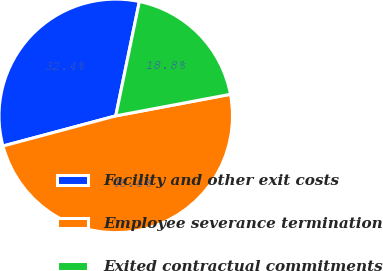<chart> <loc_0><loc_0><loc_500><loc_500><pie_chart><fcel>Facility and other exit costs<fcel>Employee severance termination<fcel>Exited contractual commitments<nl><fcel>32.4%<fcel>48.8%<fcel>18.8%<nl></chart> 